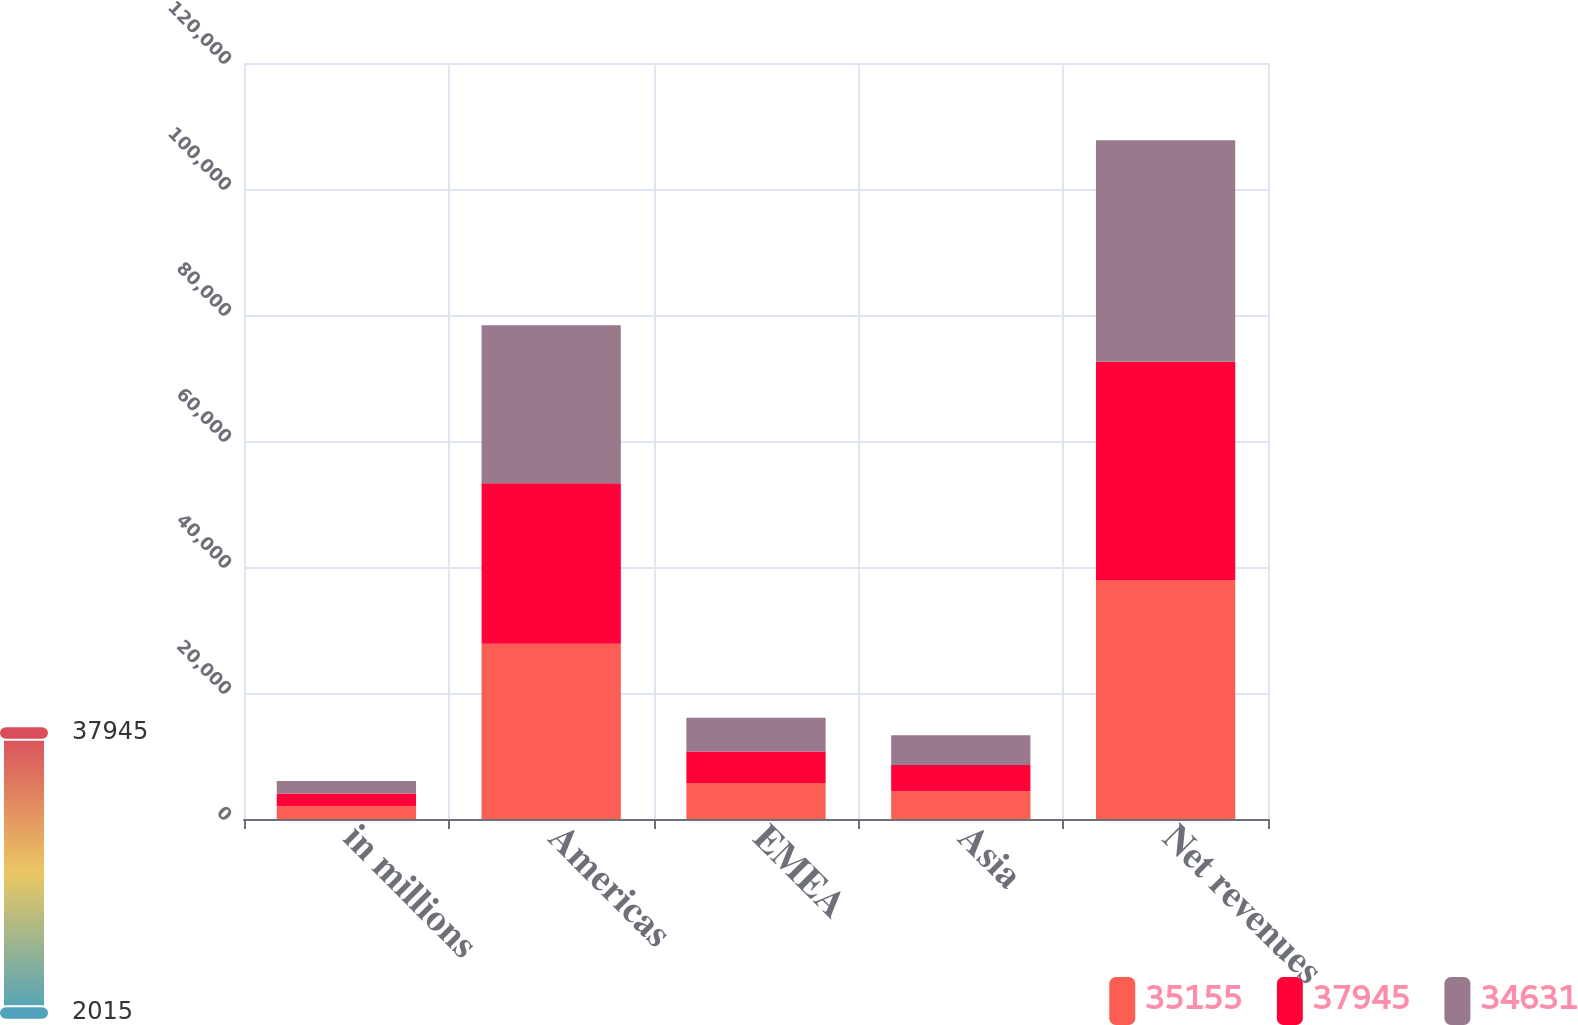Convert chart to OTSL. <chart><loc_0><loc_0><loc_500><loc_500><stacked_bar_chart><ecel><fcel>in millions<fcel>Americas<fcel>EMEA<fcel>Asia<fcel>Net revenues<nl><fcel>35155<fcel>2017<fcel>27817<fcel>5714<fcel>4414<fcel>37945<nl><fcel>37945<fcel>2016<fcel>25487<fcel>4994<fcel>4150<fcel>34631<nl><fcel>34631<fcel>2015<fcel>25080<fcel>5353<fcel>4722<fcel>35155<nl></chart> 